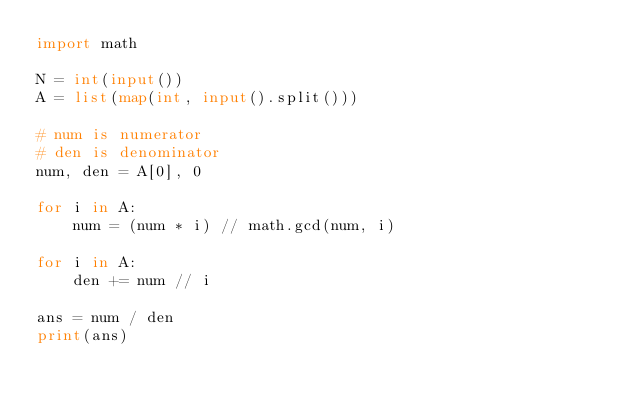<code> <loc_0><loc_0><loc_500><loc_500><_Python_>import math

N = int(input())
A = list(map(int, input().split()))

# num is numerator
# den is denominator
num, den = A[0], 0

for i in A:
    num = (num * i) // math.gcd(num, i)

for i in A:
    den += num // i

ans = num / den
print(ans)
</code> 